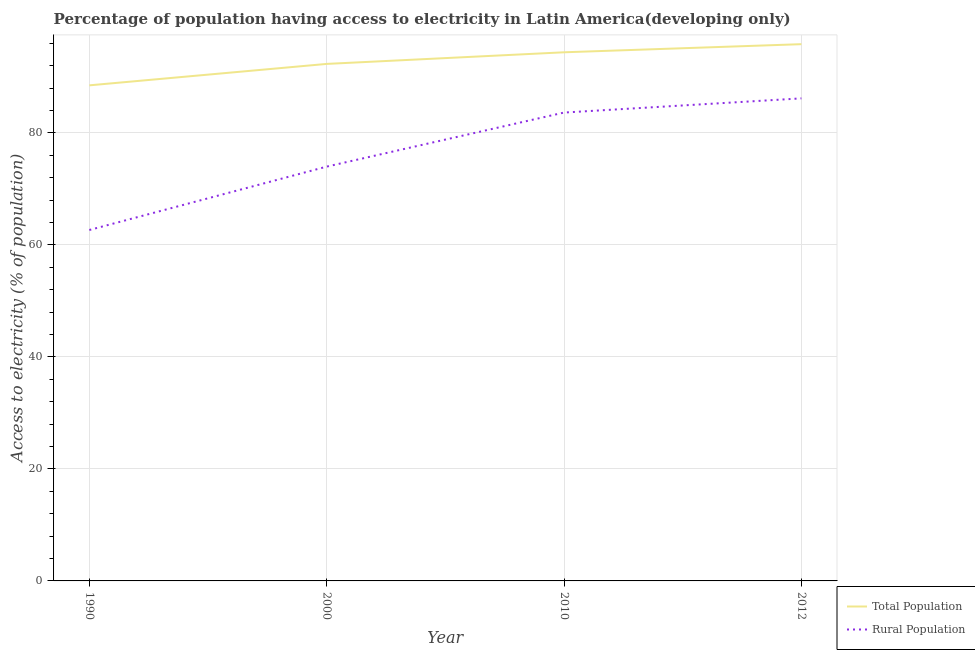How many different coloured lines are there?
Provide a succinct answer. 2. Is the number of lines equal to the number of legend labels?
Keep it short and to the point. Yes. What is the percentage of rural population having access to electricity in 2000?
Your response must be concise. 73.97. Across all years, what is the maximum percentage of rural population having access to electricity?
Provide a short and direct response. 86.15. Across all years, what is the minimum percentage of rural population having access to electricity?
Provide a succinct answer. 62.65. In which year was the percentage of rural population having access to electricity maximum?
Offer a very short reply. 2012. What is the total percentage of rural population having access to electricity in the graph?
Keep it short and to the point. 306.39. What is the difference between the percentage of population having access to electricity in 2010 and that in 2012?
Make the answer very short. -1.45. What is the difference between the percentage of population having access to electricity in 2000 and the percentage of rural population having access to electricity in 2012?
Your answer should be compact. 6.15. What is the average percentage of rural population having access to electricity per year?
Keep it short and to the point. 76.6. In the year 2012, what is the difference between the percentage of rural population having access to electricity and percentage of population having access to electricity?
Give a very brief answer. -9.68. What is the ratio of the percentage of population having access to electricity in 1990 to that in 2010?
Ensure brevity in your answer.  0.94. Is the percentage of population having access to electricity in 2000 less than that in 2010?
Your answer should be compact. Yes. What is the difference between the highest and the second highest percentage of population having access to electricity?
Make the answer very short. 1.45. What is the difference between the highest and the lowest percentage of population having access to electricity?
Keep it short and to the point. 7.35. In how many years, is the percentage of rural population having access to electricity greater than the average percentage of rural population having access to electricity taken over all years?
Give a very brief answer. 2. Is the percentage of rural population having access to electricity strictly greater than the percentage of population having access to electricity over the years?
Offer a terse response. No. Is the percentage of rural population having access to electricity strictly less than the percentage of population having access to electricity over the years?
Provide a succinct answer. Yes. How many lines are there?
Provide a short and direct response. 2. How many years are there in the graph?
Provide a short and direct response. 4. Are the values on the major ticks of Y-axis written in scientific E-notation?
Your response must be concise. No. Does the graph contain any zero values?
Offer a terse response. No. Does the graph contain grids?
Provide a short and direct response. Yes. What is the title of the graph?
Give a very brief answer. Percentage of population having access to electricity in Latin America(developing only). Does "Age 65(female)" appear as one of the legend labels in the graph?
Your response must be concise. No. What is the label or title of the X-axis?
Give a very brief answer. Year. What is the label or title of the Y-axis?
Your answer should be compact. Access to electricity (% of population). What is the Access to electricity (% of population) of Total Population in 1990?
Provide a short and direct response. 88.48. What is the Access to electricity (% of population) of Rural Population in 1990?
Provide a succinct answer. 62.65. What is the Access to electricity (% of population) in Total Population in 2000?
Give a very brief answer. 92.3. What is the Access to electricity (% of population) in Rural Population in 2000?
Your answer should be very brief. 73.97. What is the Access to electricity (% of population) in Total Population in 2010?
Your response must be concise. 94.38. What is the Access to electricity (% of population) of Rural Population in 2010?
Ensure brevity in your answer.  83.62. What is the Access to electricity (% of population) of Total Population in 2012?
Provide a short and direct response. 95.83. What is the Access to electricity (% of population) of Rural Population in 2012?
Your response must be concise. 86.15. Across all years, what is the maximum Access to electricity (% of population) in Total Population?
Provide a succinct answer. 95.83. Across all years, what is the maximum Access to electricity (% of population) of Rural Population?
Your response must be concise. 86.15. Across all years, what is the minimum Access to electricity (% of population) of Total Population?
Offer a terse response. 88.48. Across all years, what is the minimum Access to electricity (% of population) of Rural Population?
Your answer should be very brief. 62.65. What is the total Access to electricity (% of population) in Total Population in the graph?
Offer a very short reply. 370.99. What is the total Access to electricity (% of population) in Rural Population in the graph?
Give a very brief answer. 306.39. What is the difference between the Access to electricity (% of population) of Total Population in 1990 and that in 2000?
Provide a succinct answer. -3.83. What is the difference between the Access to electricity (% of population) in Rural Population in 1990 and that in 2000?
Give a very brief answer. -11.32. What is the difference between the Access to electricity (% of population) in Total Population in 1990 and that in 2010?
Give a very brief answer. -5.9. What is the difference between the Access to electricity (% of population) in Rural Population in 1990 and that in 2010?
Ensure brevity in your answer.  -20.97. What is the difference between the Access to electricity (% of population) in Total Population in 1990 and that in 2012?
Offer a terse response. -7.35. What is the difference between the Access to electricity (% of population) in Rural Population in 1990 and that in 2012?
Your answer should be very brief. -23.5. What is the difference between the Access to electricity (% of population) in Total Population in 2000 and that in 2010?
Your answer should be compact. -2.07. What is the difference between the Access to electricity (% of population) of Rural Population in 2000 and that in 2010?
Your answer should be very brief. -9.65. What is the difference between the Access to electricity (% of population) of Total Population in 2000 and that in 2012?
Offer a terse response. -3.52. What is the difference between the Access to electricity (% of population) of Rural Population in 2000 and that in 2012?
Offer a very short reply. -12.19. What is the difference between the Access to electricity (% of population) in Total Population in 2010 and that in 2012?
Provide a succinct answer. -1.45. What is the difference between the Access to electricity (% of population) of Rural Population in 2010 and that in 2012?
Give a very brief answer. -2.53. What is the difference between the Access to electricity (% of population) of Total Population in 1990 and the Access to electricity (% of population) of Rural Population in 2000?
Ensure brevity in your answer.  14.51. What is the difference between the Access to electricity (% of population) of Total Population in 1990 and the Access to electricity (% of population) of Rural Population in 2010?
Provide a succinct answer. 4.86. What is the difference between the Access to electricity (% of population) in Total Population in 1990 and the Access to electricity (% of population) in Rural Population in 2012?
Your answer should be very brief. 2.32. What is the difference between the Access to electricity (% of population) of Total Population in 2000 and the Access to electricity (% of population) of Rural Population in 2010?
Your answer should be compact. 8.68. What is the difference between the Access to electricity (% of population) of Total Population in 2000 and the Access to electricity (% of population) of Rural Population in 2012?
Your answer should be very brief. 6.15. What is the difference between the Access to electricity (% of population) in Total Population in 2010 and the Access to electricity (% of population) in Rural Population in 2012?
Keep it short and to the point. 8.22. What is the average Access to electricity (% of population) of Total Population per year?
Keep it short and to the point. 92.75. What is the average Access to electricity (% of population) of Rural Population per year?
Make the answer very short. 76.6. In the year 1990, what is the difference between the Access to electricity (% of population) in Total Population and Access to electricity (% of population) in Rural Population?
Provide a short and direct response. 25.82. In the year 2000, what is the difference between the Access to electricity (% of population) in Total Population and Access to electricity (% of population) in Rural Population?
Your answer should be compact. 18.34. In the year 2010, what is the difference between the Access to electricity (% of population) in Total Population and Access to electricity (% of population) in Rural Population?
Your answer should be compact. 10.76. In the year 2012, what is the difference between the Access to electricity (% of population) in Total Population and Access to electricity (% of population) in Rural Population?
Make the answer very short. 9.68. What is the ratio of the Access to electricity (% of population) of Total Population in 1990 to that in 2000?
Keep it short and to the point. 0.96. What is the ratio of the Access to electricity (% of population) of Rural Population in 1990 to that in 2000?
Keep it short and to the point. 0.85. What is the ratio of the Access to electricity (% of population) in Total Population in 1990 to that in 2010?
Offer a very short reply. 0.94. What is the ratio of the Access to electricity (% of population) of Rural Population in 1990 to that in 2010?
Provide a short and direct response. 0.75. What is the ratio of the Access to electricity (% of population) in Total Population in 1990 to that in 2012?
Provide a succinct answer. 0.92. What is the ratio of the Access to electricity (% of population) of Rural Population in 1990 to that in 2012?
Offer a very short reply. 0.73. What is the ratio of the Access to electricity (% of population) in Total Population in 2000 to that in 2010?
Ensure brevity in your answer.  0.98. What is the ratio of the Access to electricity (% of population) in Rural Population in 2000 to that in 2010?
Make the answer very short. 0.88. What is the ratio of the Access to electricity (% of population) in Total Population in 2000 to that in 2012?
Ensure brevity in your answer.  0.96. What is the ratio of the Access to electricity (% of population) in Rural Population in 2000 to that in 2012?
Give a very brief answer. 0.86. What is the ratio of the Access to electricity (% of population) of Total Population in 2010 to that in 2012?
Ensure brevity in your answer.  0.98. What is the ratio of the Access to electricity (% of population) of Rural Population in 2010 to that in 2012?
Your answer should be very brief. 0.97. What is the difference between the highest and the second highest Access to electricity (% of population) in Total Population?
Provide a short and direct response. 1.45. What is the difference between the highest and the second highest Access to electricity (% of population) of Rural Population?
Ensure brevity in your answer.  2.53. What is the difference between the highest and the lowest Access to electricity (% of population) in Total Population?
Make the answer very short. 7.35. What is the difference between the highest and the lowest Access to electricity (% of population) in Rural Population?
Offer a very short reply. 23.5. 